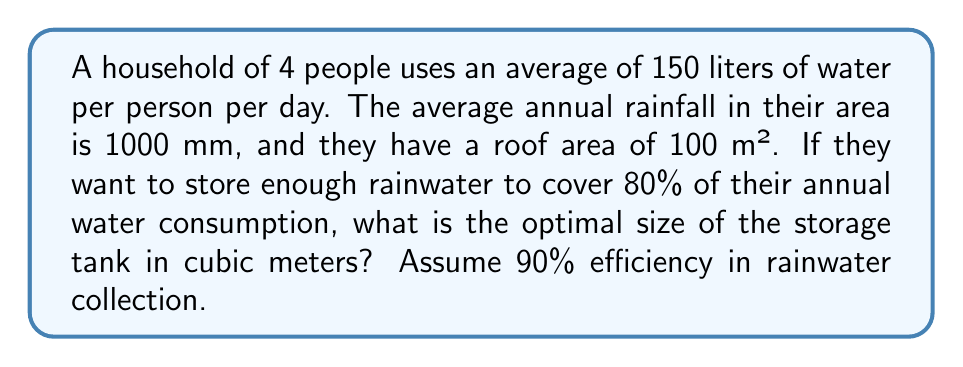Give your solution to this math problem. Let's approach this step-by-step:

1. Calculate the annual water consumption:
   $$ \text{Annual consumption} = 4 \text{ people} \times 150 \text{ L/person/day} \times 365 \text{ days} = 219,000 \text{ L} $$

2. Calculate the amount of water they want to store (80% of annual consumption):
   $$ \text{Water to store} = 219,000 \text{ L} \times 0.80 = 175,200 \text{ L} $$

3. Calculate the annual rainwater that can be collected:
   - Rainfall volume = Roof area × Annual rainfall × Collection efficiency
   $$ \text{Rainfall volume} = 100 \text{ m}^2 \times 1000 \text{ mm} \times 0.90 = 90,000 \text{ L} $$

4. The optimal tank size should be the smaller of the two values:
   a) Water they want to store: 175,200 L
   b) Annual rainwater collection: 90,000 L

   We choose 90,000 L as the optimal size to avoid oversizing the tank.

5. Convert liters to cubic meters:
   $$ 90,000 \text{ L} \times \frac{1 \text{ m}^3}{1000 \text{ L}} = 90 \text{ m}^3 $$

Therefore, the optimal size of the storage tank is 90 cubic meters.
Answer: 90 m³ 